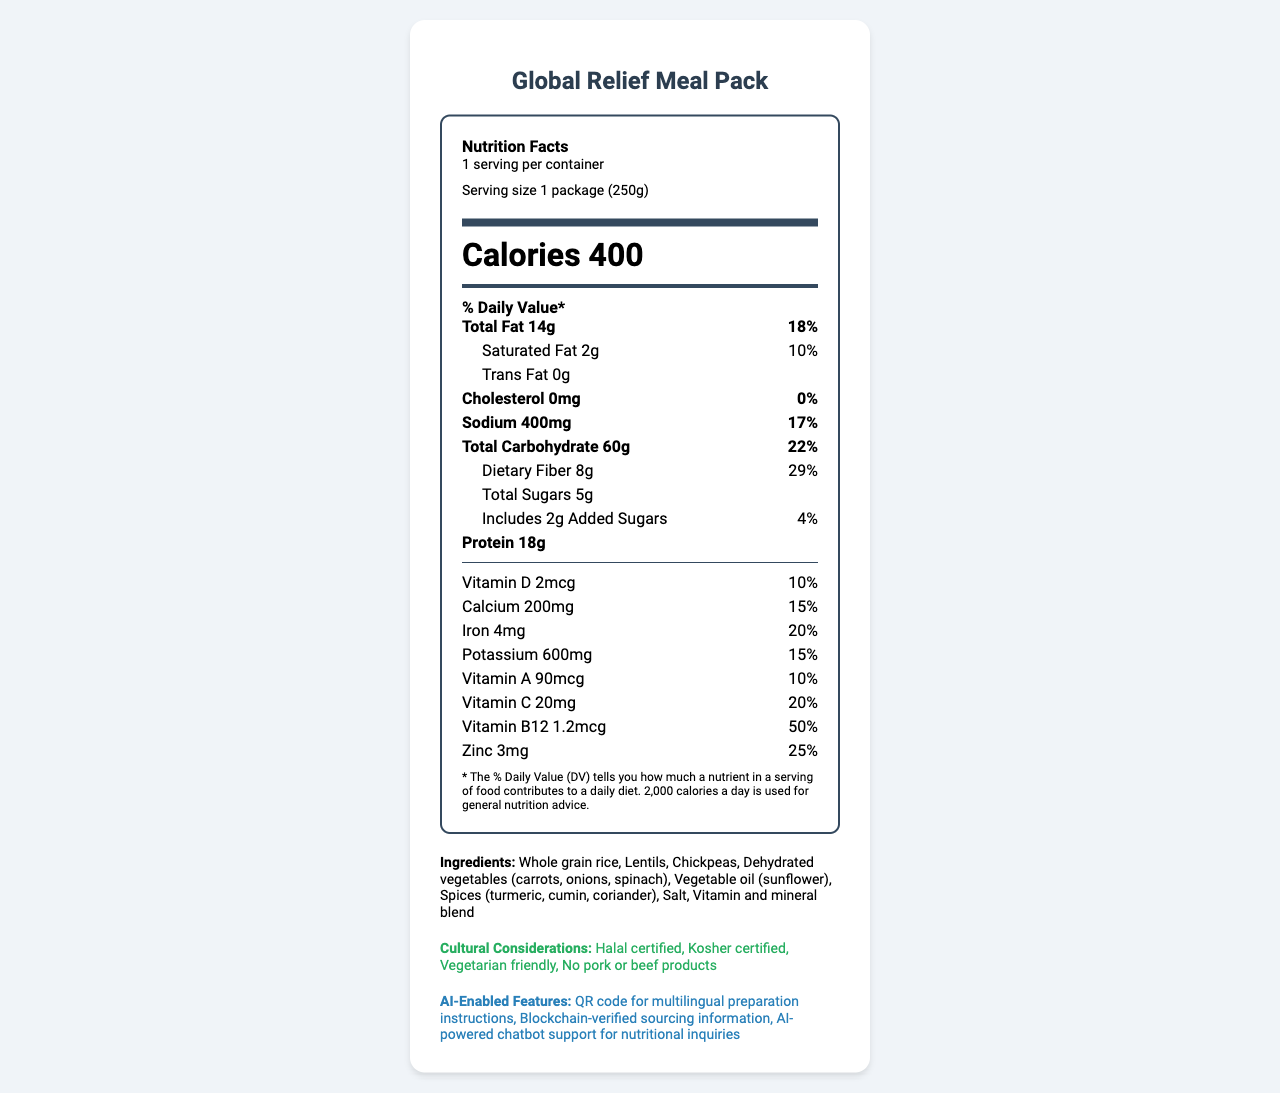what is the product name mentioned? The product name is mentioned at the top of the document as "Global Relief Meal Pack."
Answer: Global Relief Meal Pack what is the serving size of the product? The serving size is specified under the "Nutrition Facts" section as "1 package (250g)."
Answer: 1 package (250g) how many calories are in one serving of this meal pack? The calories per serving are displayed prominently under the "Nutrition Facts" header as "Calories 400."
Answer: 400 what is the total fat content and its daily value percentage? The total fat content is stated as "Total Fat 14g" with a daily value percentage of 18%.
Answer: 14g, 18% what are the main ingredients in this meal pack? The main ingredients are listed under the "Ingredients" section of the document.
Answer: Whole grain rice, Lentils, Chickpeas, Dehydrated vegetables (carrots, onions, spinach), Vegetable oil (sunflower), Spices (turmeric, cumin, coriander), Salt, Vitamin and mineral blend which vitamins and minerals have the highest daily value percentage? A. Vitamin C and Iron B. Vitamin B12 and Vitamin D C. Zinc and Vitamin C Vitamin C has a daily value of 20%, and Zinc has a daily value of 25%, which are the highest percentages mentioned in the list of nutrients.
Answer: C. Zinc and Vitamin C what is the daily value percentage for Sodium? A. 10% B. 17% C. 29% D. 22% The daily value percentage for Sodium is listed as 17%.
Answer: B. 17% does the product contain any common allergens? The document explicitly states in the "allergen_info" section that it contains no common allergens.
Answer: No is the product Halal certified? The "Cultural Considerations" section mentions that the product is Halal certified.
Answer: Yes what are the AI-enabled features of this product? The AI-enabled features are listed under the relevant section as including a QR code for multilingual preparation instructions, Blockchain-verified sourcing information, and AI-powered chatbot support for nutritional inquiries.
Answer: QR code for multilingual preparation instructions, Blockchain-verified sourcing information, AI-powered chatbot support for nutritional inquiries summarize the main information provided in this document. The document contains detailed information about the nutritional content, ingredients, cultural certifications, sustainability aspects, and AI-enabled features of the Global Relief Meal Pack. It also provides preparation and storage instructions and offers contact details for further inquiries.
Answer: The document provides nutritional information for the Global Relief Meal Pack, detailing serving size, calorie content, and daily values of various nutrients. It lists ingredients, allergen information, preparation, and storage instructions, and highlights cultural considerations such as Halal and Kosher certifications. Sustainability and AI-enabled features are also mentioned, along with contact information for the manufacturer. what is the source of funding for this product? The document does not provide any information regarding the source of funding for this product.
Answer: Cannot be determined 